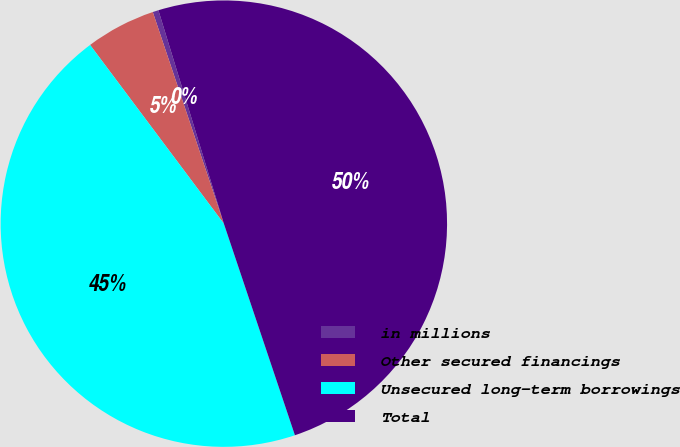Convert chart. <chart><loc_0><loc_0><loc_500><loc_500><pie_chart><fcel>in millions<fcel>Other secured financings<fcel>Unsecured long-term borrowings<fcel>Total<nl><fcel>0.42%<fcel>5.07%<fcel>44.93%<fcel>49.58%<nl></chart> 